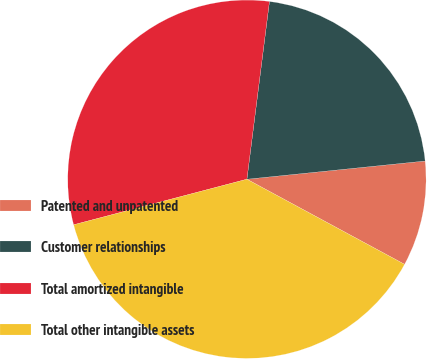<chart> <loc_0><loc_0><loc_500><loc_500><pie_chart><fcel>Patented and unpatented<fcel>Customer relationships<fcel>Total amortized intangible<fcel>Total other intangible assets<nl><fcel>9.5%<fcel>21.37%<fcel>31.1%<fcel>38.03%<nl></chart> 